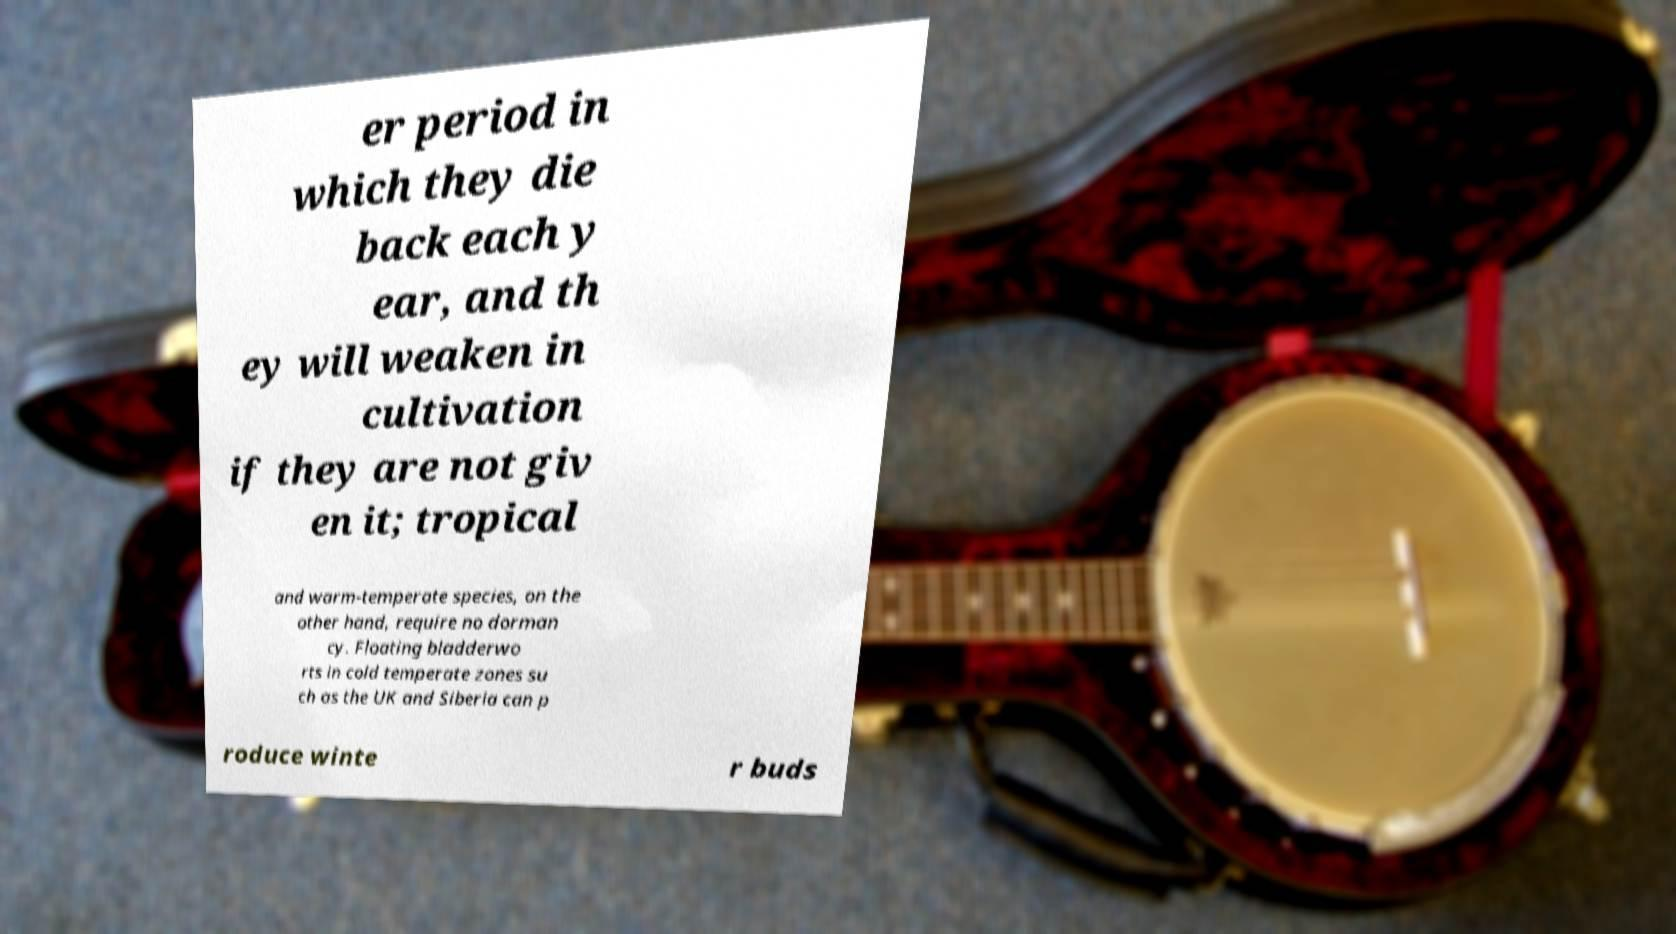Can you read and provide the text displayed in the image?This photo seems to have some interesting text. Can you extract and type it out for me? er period in which they die back each y ear, and th ey will weaken in cultivation if they are not giv en it; tropical and warm-temperate species, on the other hand, require no dorman cy. Floating bladderwo rts in cold temperate zones su ch as the UK and Siberia can p roduce winte r buds 